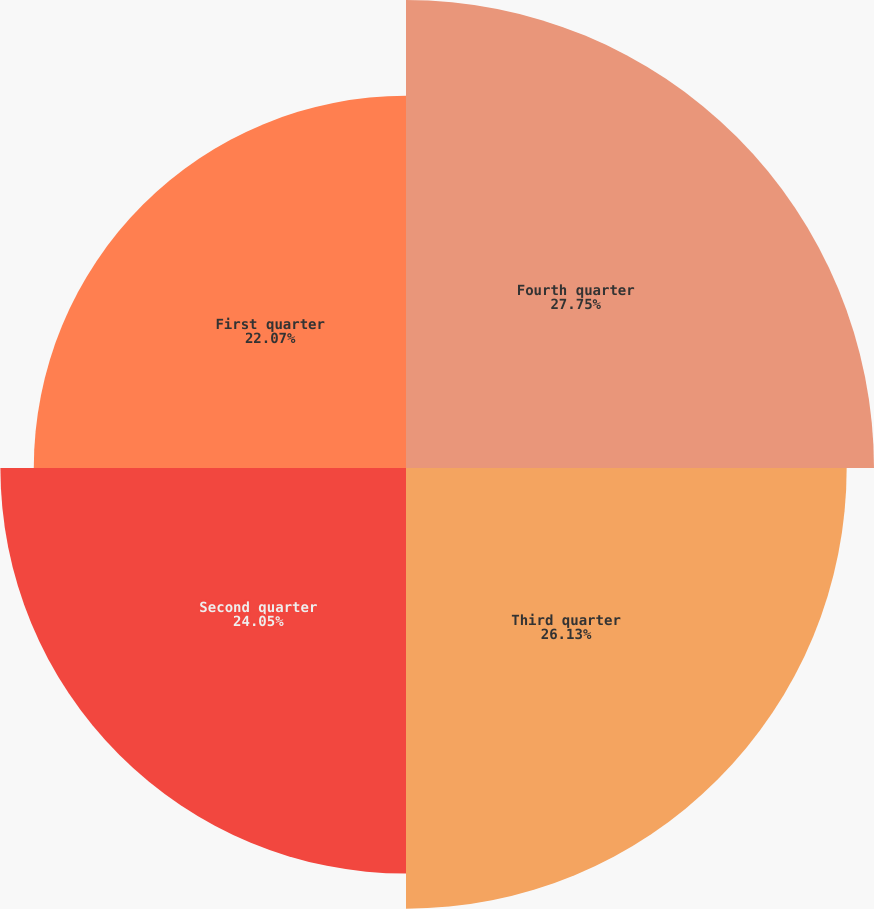<chart> <loc_0><loc_0><loc_500><loc_500><pie_chart><fcel>Fourth quarter<fcel>Third quarter<fcel>Second quarter<fcel>First quarter<nl><fcel>27.75%<fcel>26.13%<fcel>24.05%<fcel>22.07%<nl></chart> 